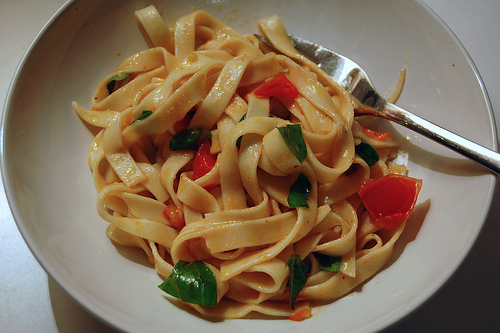<image>
Is there a fork on the table? No. The fork is not positioned on the table. They may be near each other, but the fork is not supported by or resting on top of the table. 